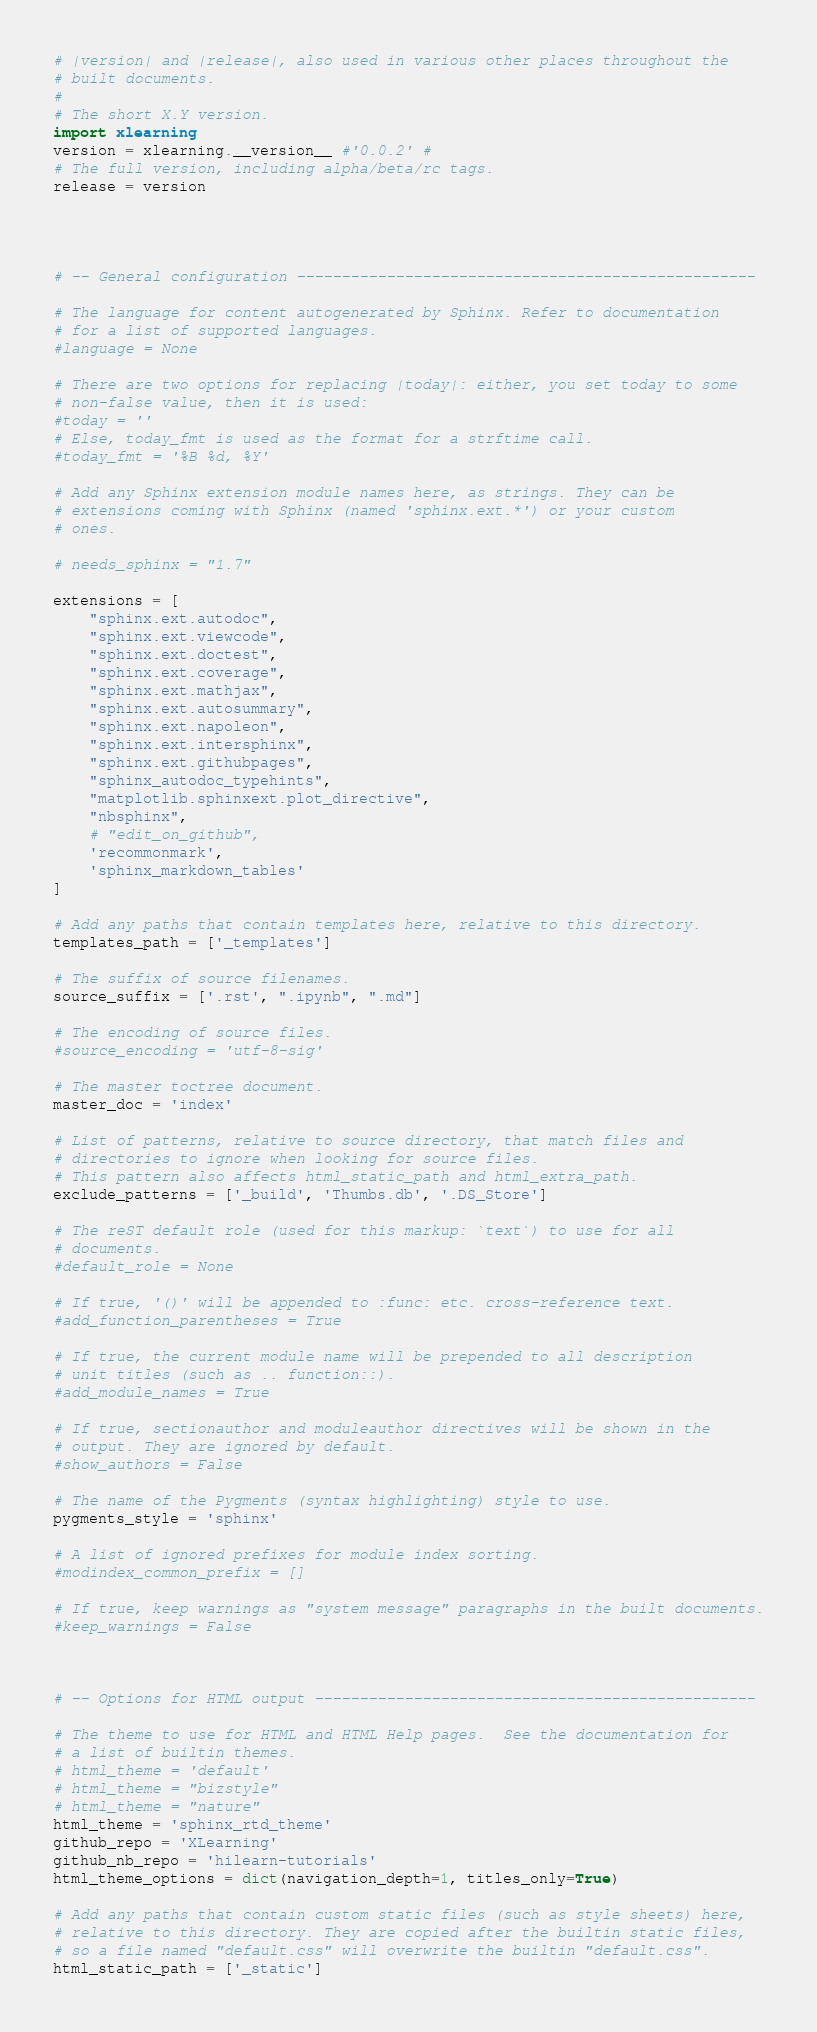<code> <loc_0><loc_0><loc_500><loc_500><_Python_># |version| and |release|, also used in various other places throughout the
# built documents.
#
# The short X.Y version.
import xlearning
version = xlearning.__version__ #'0.0.2' #
# The full version, including alpha/beta/rc tags.
release = version




# -- General configuration ---------------------------------------------------

# The language for content autogenerated by Sphinx. Refer to documentation
# for a list of supported languages.
#language = None

# There are two options for replacing |today|: either, you set today to some
# non-false value, then it is used:
#today = ''
# Else, today_fmt is used as the format for a strftime call.
#today_fmt = '%B %d, %Y'

# Add any Sphinx extension module names here, as strings. They can be
# extensions coming with Sphinx (named 'sphinx.ext.*') or your custom
# ones.

# needs_sphinx = "1.7"

extensions = [
    "sphinx.ext.autodoc",
    "sphinx.ext.viewcode",
    "sphinx.ext.doctest",
    "sphinx.ext.coverage",
    "sphinx.ext.mathjax",
    "sphinx.ext.autosummary",
    "sphinx.ext.napoleon",
    "sphinx.ext.intersphinx",
    "sphinx.ext.githubpages",
    "sphinx_autodoc_typehints",
    "matplotlib.sphinxext.plot_directive",
    "nbsphinx",
    # "edit_on_github",
    'recommonmark',
    'sphinx_markdown_tables'
]

# Add any paths that contain templates here, relative to this directory.
templates_path = ['_templates']

# The suffix of source filenames.
source_suffix = ['.rst', ".ipynb", ".md"]

# The encoding of source files.
#source_encoding = 'utf-8-sig'

# The master toctree document.
master_doc = 'index'

# List of patterns, relative to source directory, that match files and
# directories to ignore when looking for source files.
# This pattern also affects html_static_path and html_extra_path.
exclude_patterns = ['_build', 'Thumbs.db', '.DS_Store']

# The reST default role (used for this markup: `text`) to use for all
# documents.
#default_role = None

# If true, '()' will be appended to :func: etc. cross-reference text.
#add_function_parentheses = True

# If true, the current module name will be prepended to all description
# unit titles (such as .. function::).
#add_module_names = True

# If true, sectionauthor and moduleauthor directives will be shown in the
# output. They are ignored by default.
#show_authors = False

# The name of the Pygments (syntax highlighting) style to use.
pygments_style = 'sphinx'

# A list of ignored prefixes for module index sorting.
#modindex_common_prefix = []

# If true, keep warnings as "system message" paragraphs in the built documents.
#keep_warnings = False



# -- Options for HTML output -------------------------------------------------

# The theme to use for HTML and HTML Help pages.  See the documentation for
# a list of builtin themes.
# html_theme = 'default'
# html_theme = "bizstyle"
# html_theme = "nature"
html_theme = 'sphinx_rtd_theme'
github_repo = 'XLearning'
github_nb_repo = 'hilearn-tutorials'
html_theme_options = dict(navigation_depth=1, titles_only=True)

# Add any paths that contain custom static files (such as style sheets) here,
# relative to this directory. They are copied after the builtin static files,
# so a file named "default.css" will overwrite the builtin "default.css".
html_static_path = ['_static']</code> 